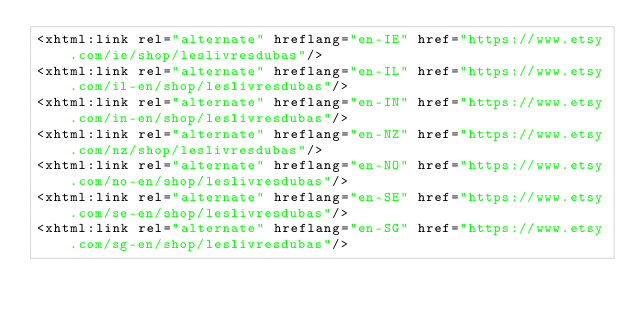Convert code to text. <code><loc_0><loc_0><loc_500><loc_500><_XML_><xhtml:link rel="alternate" hreflang="en-IE" href="https://www.etsy.com/ie/shop/leslivresdubas"/>
<xhtml:link rel="alternate" hreflang="en-IL" href="https://www.etsy.com/il-en/shop/leslivresdubas"/>
<xhtml:link rel="alternate" hreflang="en-IN" href="https://www.etsy.com/in-en/shop/leslivresdubas"/>
<xhtml:link rel="alternate" hreflang="en-NZ" href="https://www.etsy.com/nz/shop/leslivresdubas"/>
<xhtml:link rel="alternate" hreflang="en-NO" href="https://www.etsy.com/no-en/shop/leslivresdubas"/>
<xhtml:link rel="alternate" hreflang="en-SE" href="https://www.etsy.com/se-en/shop/leslivresdubas"/>
<xhtml:link rel="alternate" hreflang="en-SG" href="https://www.etsy.com/sg-en/shop/leslivresdubas"/></code> 